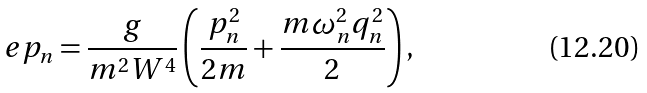<formula> <loc_0><loc_0><loc_500><loc_500>\ e p _ { n } = \frac { g } { m ^ { 2 } W ^ { 4 } } \left ( \frac { p _ { n } ^ { 2 } } { 2 m } + \frac { m \omega _ { n } ^ { 2 } q _ { n } ^ { 2 } } { 2 } \right ) ,</formula> 